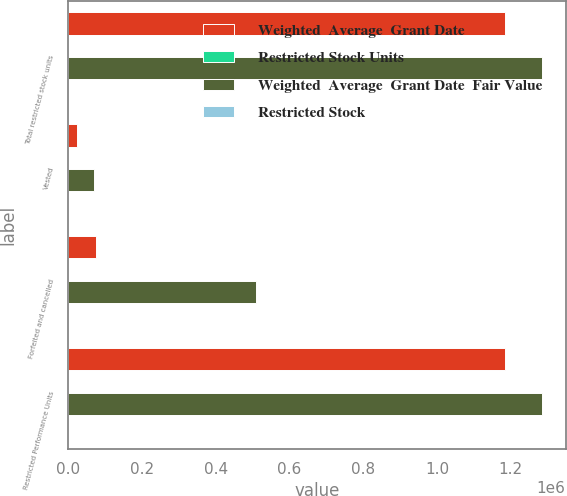Convert chart. <chart><loc_0><loc_0><loc_500><loc_500><stacked_bar_chart><ecel><fcel>Total restricted stock units<fcel>Vested<fcel>Forfeited and cancelled<fcel>Restricted Performance Units<nl><fcel>Weighted  Average  Grant Date<fcel>1.18508e+06<fcel>24795<fcel>74833<fcel>1.18508e+06<nl><fcel>Restricted Stock Units<fcel>22.99<fcel>22.94<fcel>27.33<fcel>22.99<nl><fcel>Weighted  Average  Grant Date  Fair Value<fcel>1.28471e+06<fcel>70830<fcel>508794<fcel>1.28471e+06<nl><fcel>Restricted Stock<fcel>23<fcel>31.36<fcel>23.77<fcel>22.61<nl></chart> 